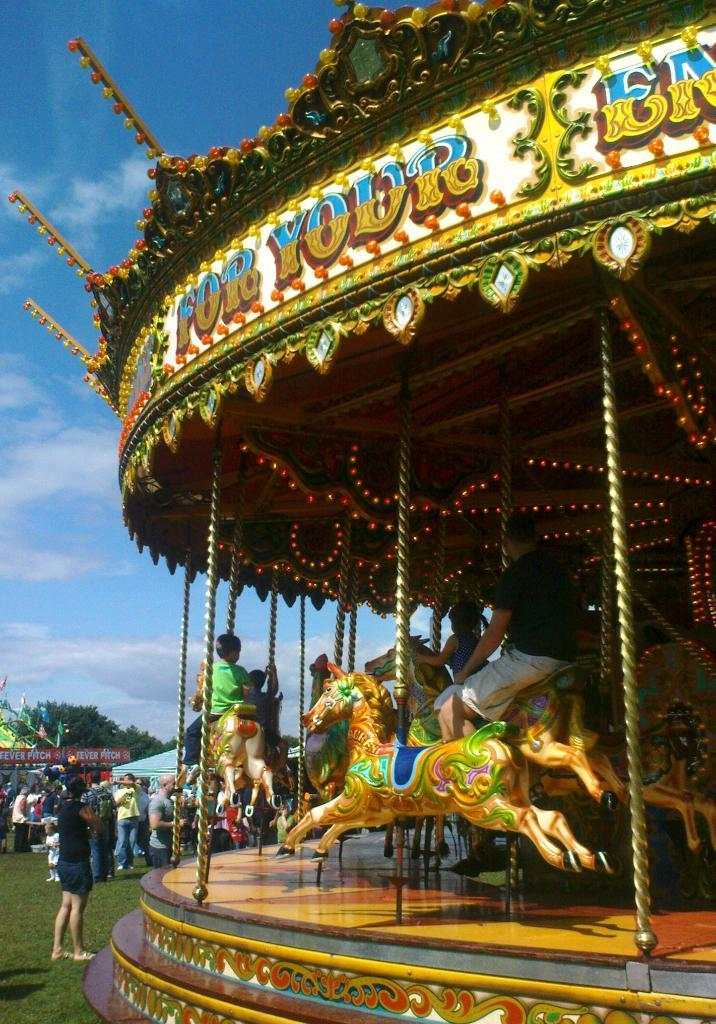Who or what can be seen in the image? There are people in the image. What else is present in the image besides people? There are trees and fun rides in the image. What are some people doing in the image? Some people are sitting on the fun rides. What can be seen in the sky in the image? There are clouds visible in the sky. What type of wood is used to build the fun rides in the image? There is no information about the type of wood used to build the fun rides in the image. 